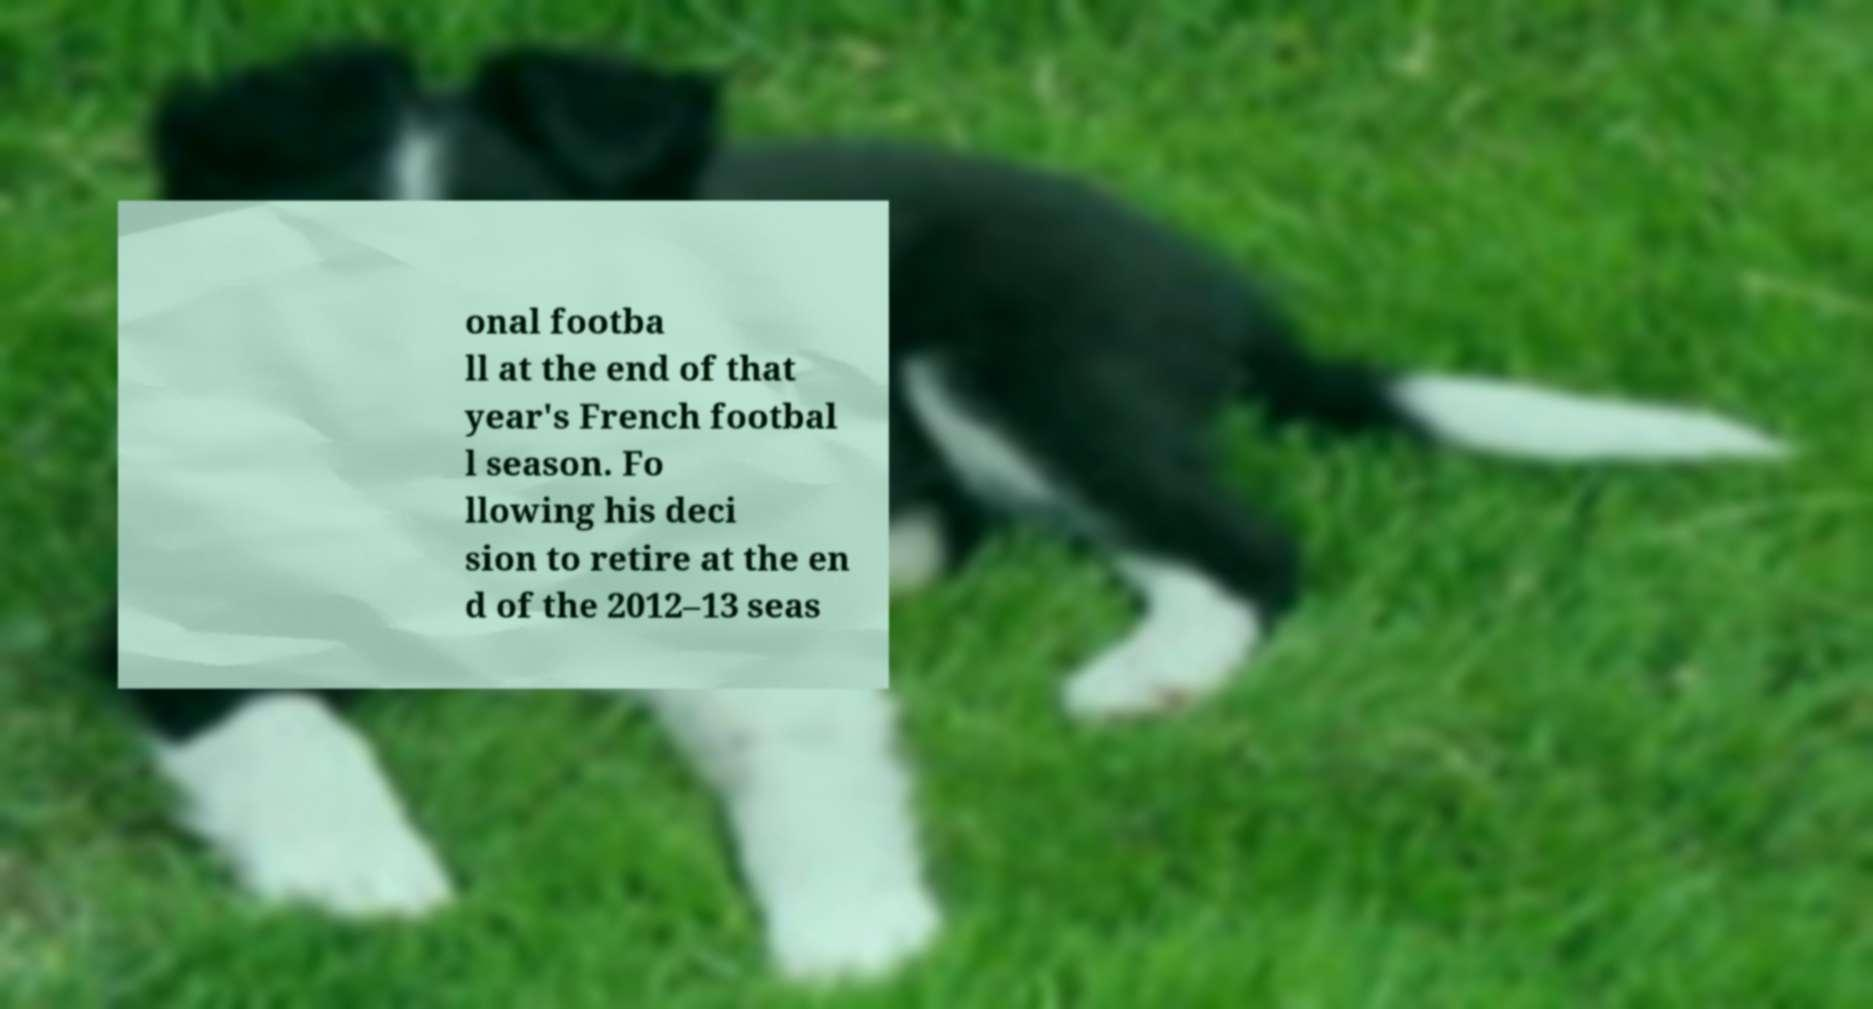For documentation purposes, I need the text within this image transcribed. Could you provide that? onal footba ll at the end of that year's French footbal l season. Fo llowing his deci sion to retire at the en d of the 2012–13 seas 